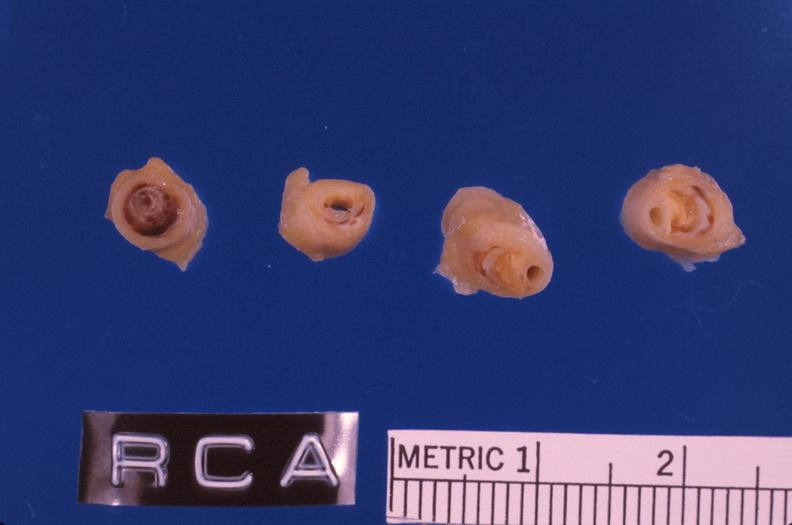s anencephaly present?
Answer the question using a single word or phrase. No 